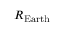<formula> <loc_0><loc_0><loc_500><loc_500>R _ { E a r t h }</formula> 